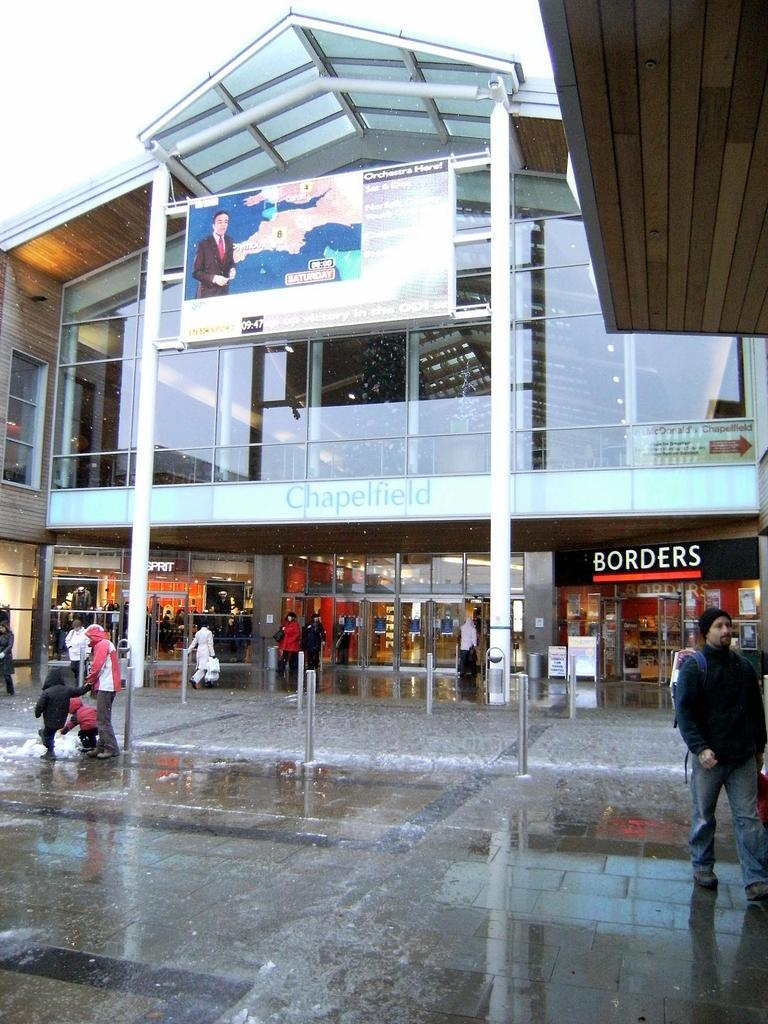What type of building is shown in the picture? There is a shopping mall in the picture. What is the appearance of the shopping mall's exterior? The shopping mall has a glass exterior. What can be found inside the shopping mall? There are shops inside the shopping mall. What is visible near the shopping mall? There is a floor visible near the shopping mall. What are the people in the picture doing? There are people walking on the floor. Can you see a hole in the shopping mall's glass exterior? There is no hole visible in the shopping mall's glass exterior in the image. How many doors are there in the shopping mall? The image does not provide enough information to determine the number of doors in the shopping mall. 